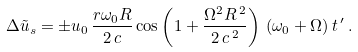Convert formula to latex. <formula><loc_0><loc_0><loc_500><loc_500>\Delta { \tilde { u } } _ { s } = \pm u _ { 0 } \, \frac { r { \omega } _ { 0 } R } { 2 \, c } \cos \left ( 1 + \frac { { \Omega } ^ { 2 } R ^ { \, 2 } } { 2 \, c ^ { \, 2 } } \right ) \, ( { \omega } _ { 0 } + \Omega ) \, t \, ^ { \prime } \, .</formula> 